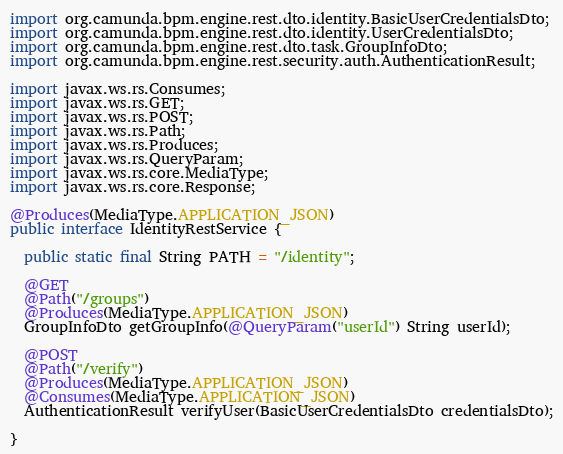Convert code to text. <code><loc_0><loc_0><loc_500><loc_500><_Java_>import org.camunda.bpm.engine.rest.dto.identity.BasicUserCredentialsDto;
import org.camunda.bpm.engine.rest.dto.identity.UserCredentialsDto;
import org.camunda.bpm.engine.rest.dto.task.GroupInfoDto;
import org.camunda.bpm.engine.rest.security.auth.AuthenticationResult;

import javax.ws.rs.Consumes;
import javax.ws.rs.GET;
import javax.ws.rs.POST;
import javax.ws.rs.Path;
import javax.ws.rs.Produces;
import javax.ws.rs.QueryParam;
import javax.ws.rs.core.MediaType;
import javax.ws.rs.core.Response;

@Produces(MediaType.APPLICATION_JSON)
public interface IdentityRestService {

  public static final String PATH = "/identity";

  @GET
  @Path("/groups")
  @Produces(MediaType.APPLICATION_JSON)
  GroupInfoDto getGroupInfo(@QueryParam("userId") String userId);

  @POST
  @Path("/verify")
  @Produces(MediaType.APPLICATION_JSON)
  @Consumes(MediaType.APPLICATION_JSON)
  AuthenticationResult verifyUser(BasicUserCredentialsDto credentialsDto);

}
</code> 